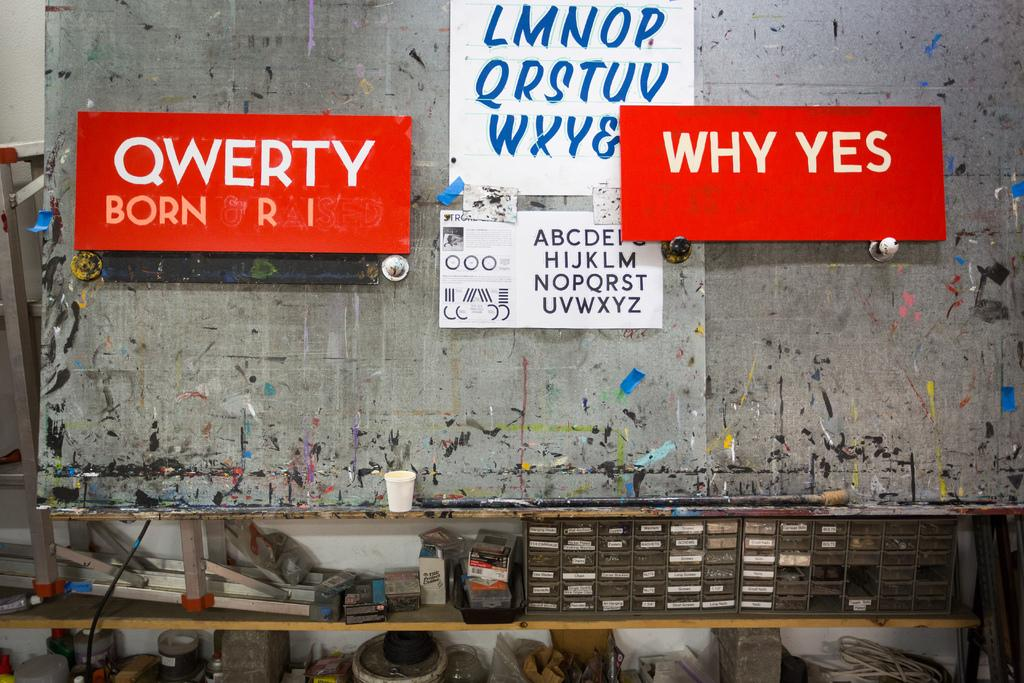<image>
Describe the image concisely. A large red sign that states "Why Yes" is hanging near two other signs on a wall. 